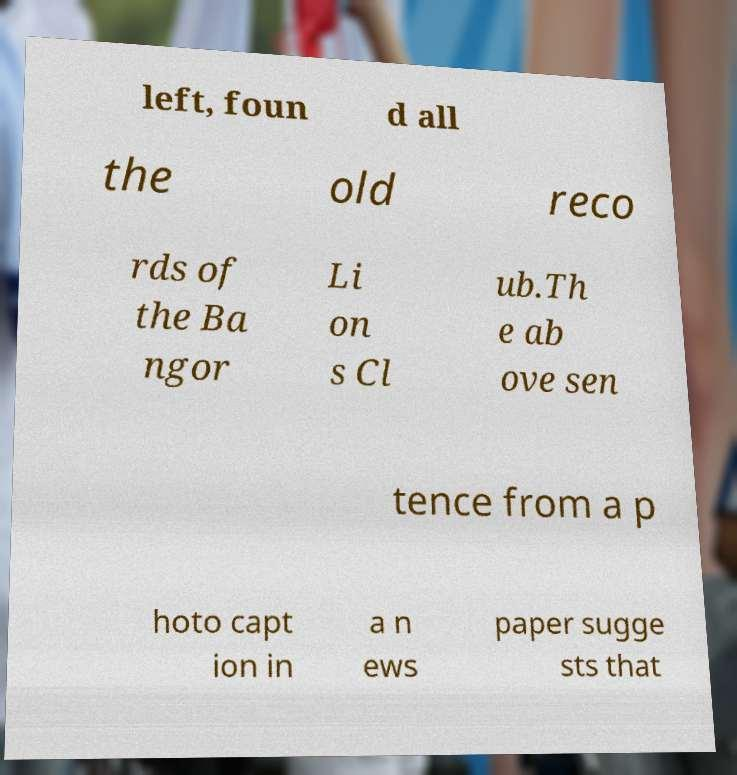I need the written content from this picture converted into text. Can you do that? left, foun d all the old reco rds of the Ba ngor Li on s Cl ub.Th e ab ove sen tence from a p hoto capt ion in a n ews paper sugge sts that 